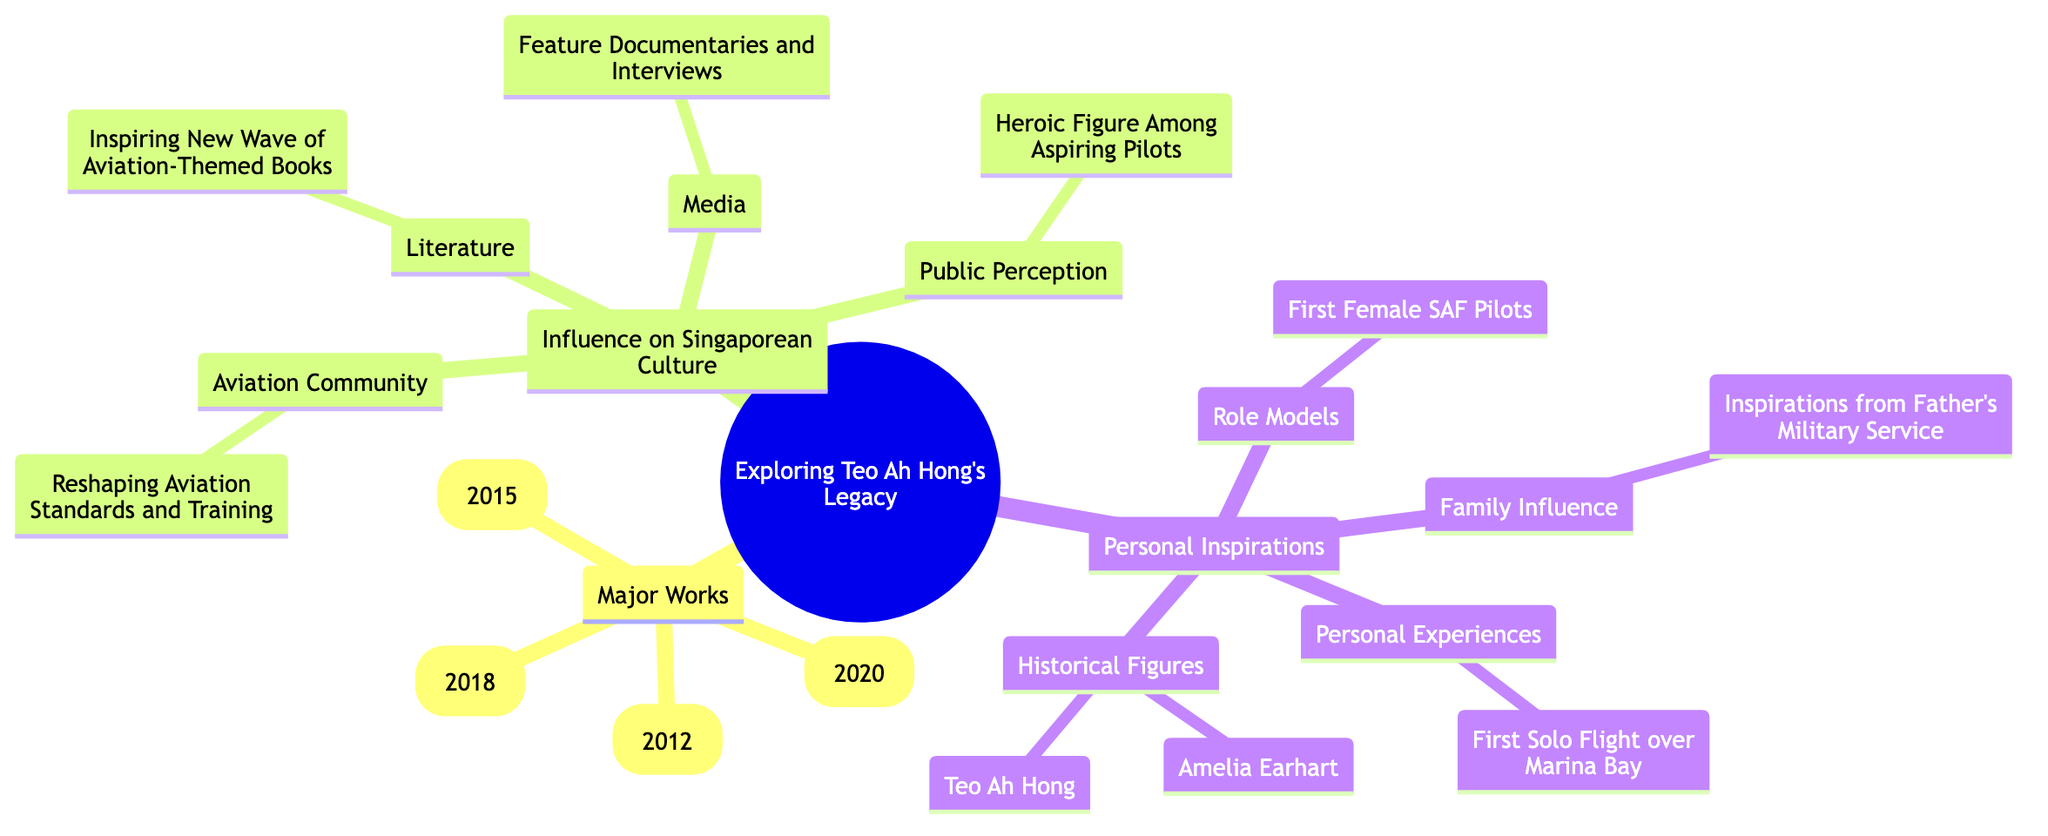What is the first major work listed under Teo Ah Hong's Legacy? The first major work under the "Major Works" section is "Wing of Freedom." This is identified as the top entry in that category within the mind map.
Answer: Wing of Freedom How many major works are listed in the diagram? The diagram shows a total of four major works under the "Major Works" section, which can be counted as follows: "Wing of Freedom," "Skyward Bound," "The Aviator's Dream," and "Pilot's Journey."
Answer: 4 What influence did Teo Ah Hong have on the media in Singapore? Teo Ah Hong influenced the media through feature documentaries and interviews that aired on Channel NewsAsia. This is specifically mentioned in the "Media" part of the "Influence on Singaporean Culture" section.
Answer: Feature Documentaries and Interviews Which historical figure besides Teo Ah Hong is listed as a personal inspiration? The historical figure listed as a personal inspiration, alongside Teo Ah Hong, is Amelia Earhart. This is mentioned under the "Historical Figures" in "Personal Inspirations."
Answer: Amelia Earhart What common theme is present in Teo Ah Hong's influence on literature? The common theme present in Teo Ah Hong's influence on literature is inspiring a new wave of aviation-themed books. This is outlined in the "Literature" section of "Influence on Singaporean Culture."
Answer: Inspiring New Wave of Aviation-Themed Books Which personal experience is highlighted in the "Personal Inspirations" section? The highlighted personal experience in the "Personal Inspirations" section is the "First Solo Flight over Marina Bay." This is directly mentioned there.
Answer: First Solo Flight over Marina Bay What is the relationship between Teo Ah Hong and the first female SAF pilots? The relationship described is that the first female SAF pilots serve as role models for those inspired by Teo Ah Hong. This connection is made in the "Role Models" part of "Personal Inspirations."
Answer: Role Models What year was "Skyward Bound" published? "Skyward Bound" was published in the year 2018, which is directly indicated in the "Major Works" section of the diagram.
Answer: 2018 In what way did Teo Ah Hong reshape the aviation community in Singapore? Teo Ah Hong reshaped the aviation community by influencing aviation standards and training in Singapore, as noted in the "Aviation Community" part of "Influence on Singaporean Culture."
Answer: Reshaping Aviation Standards and Training 